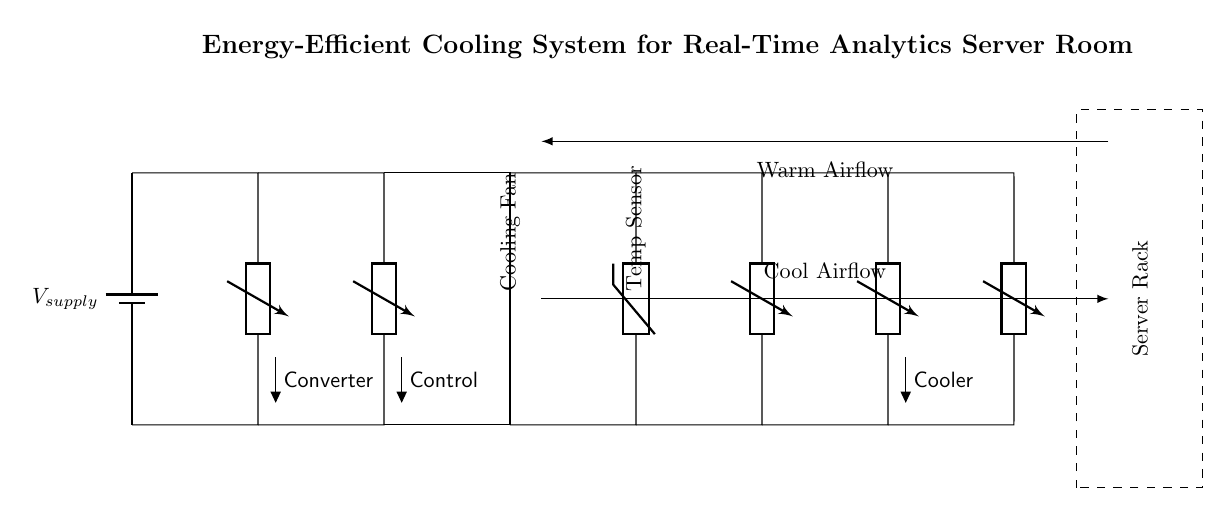What is the role of the DC-DC converter in this circuit? The DC-DC converter's role is to step down or regulate the supply voltage received from the battery to a level suitable for the rest of the components in the circuit. It ensures that the voltage remains stable and is appropriate for the connected devices.
Answer: Converter What type of cooling component is represented in this circuit? The circuit includes a cooling fan as a part of the cooling system, which actively circulates air to dissipate heat generated by the server rack. The fan is crucial for maintaining an optimal temperature in the server room.
Answer: Cooling Fan How does the temperature sensor affect the circuit? The temperature sensor monitors the temperature of the server room and sends feedback to the microcontroller, which may control the operation of the cooling fan and Peltier cooler based on temperature readings to optimize cooling efficiency.
Answer: Monitoring What component directly interfaces with the thermostat in this circuit? The thermostat is directly interfaced with the microcontroller, which utilizes the temperature readings to make decisions about activating the cooling mechanisms such as the fan and Peltier cooler.
Answer: Microcontroller What is the purpose of the Peltier cooler? The Peltier cooler is used for thermoelectric cooling, which actively removes heat from the server components, thus enhancing the overall cooling efficiency and energy savings in maintaining the desired temperature range.
Answer: Cooler Which direction does the cool airflow move in this circuit? The cool airflow moves from the cooling fan towards the server rack to provide necessary cooling, as indicated by the airflow arrows in the circuit diagram. This helps in removing heat from heated server components effectively.
Answer: Right 